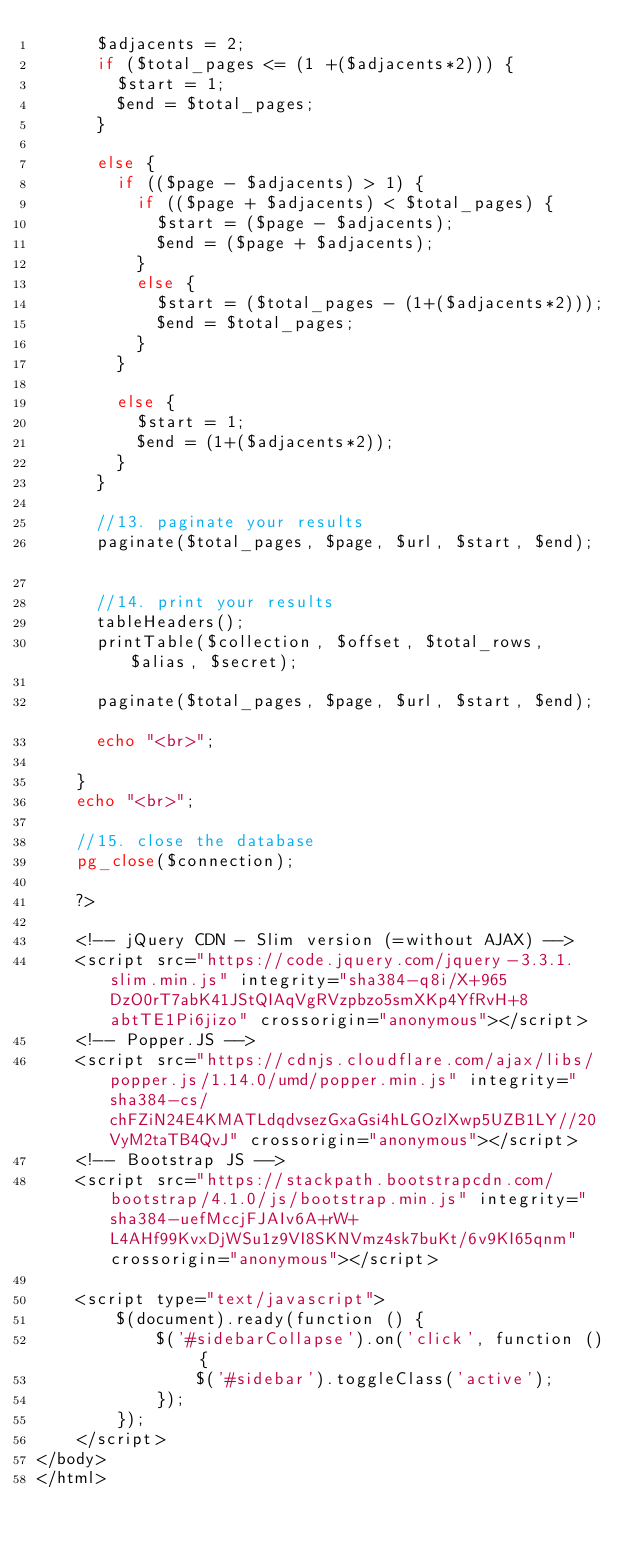<code> <loc_0><loc_0><loc_500><loc_500><_PHP_>			$adjacents = 2;			
			if ($total_pages <= (1 +($adjacents*2))) {
				$start = 1;
				$end = $total_pages;
			}
										
			else {
				if (($page - $adjacents) > 1) {
					if (($page + $adjacents) < $total_pages) {
						$start = ($page - $adjacents);
						$end = ($page + $adjacents);
					}
					else {
						$start = ($total_pages - (1+($adjacents*2)));
						$end = $total_pages;
					}
				}
											
				else {
					$start = 1;
					$end = (1+($adjacents*2));
				}
			}			
			
			//13. paginate your results
			paginate($total_pages, $page, $url, $start, $end);						
			
			//14. print your results
			tableHeaders();
			printTable($collection, $offset, $total_rows, $alias, $secret);	

			paginate($total_pages, $page, $url, $start, $end);					
			echo "<br>";
					
		} 
		echo "<br>";	
		
		//15. close the database
		pg_close($connection);	
		
		?>								

    <!-- jQuery CDN - Slim version (=without AJAX) -->
    <script src="https://code.jquery.com/jquery-3.3.1.slim.min.js" integrity="sha384-q8i/X+965DzO0rT7abK41JStQIAqVgRVzpbzo5smXKp4YfRvH+8abtTE1Pi6jizo" crossorigin="anonymous"></script>
    <!-- Popper.JS -->
    <script src="https://cdnjs.cloudflare.com/ajax/libs/popper.js/1.14.0/umd/popper.min.js" integrity="sha384-cs/chFZiN24E4KMATLdqdvsezGxaGsi4hLGOzlXwp5UZB1LY//20VyM2taTB4QvJ" crossorigin="anonymous"></script>
    <!-- Bootstrap JS -->
    <script src="https://stackpath.bootstrapcdn.com/bootstrap/4.1.0/js/bootstrap.min.js" integrity="sha384-uefMccjFJAIv6A+rW+L4AHf99KvxDjWSu1z9VI8SKNVmz4sk7buKt/6v9KI65qnm" crossorigin="anonymous"></script>

    <script type="text/javascript">
        $(document).ready(function () {
            $('#sidebarCollapse').on('click', function () {
                $('#sidebar').toggleClass('active');
            });
        });
    </script>
</body>
</html></code> 